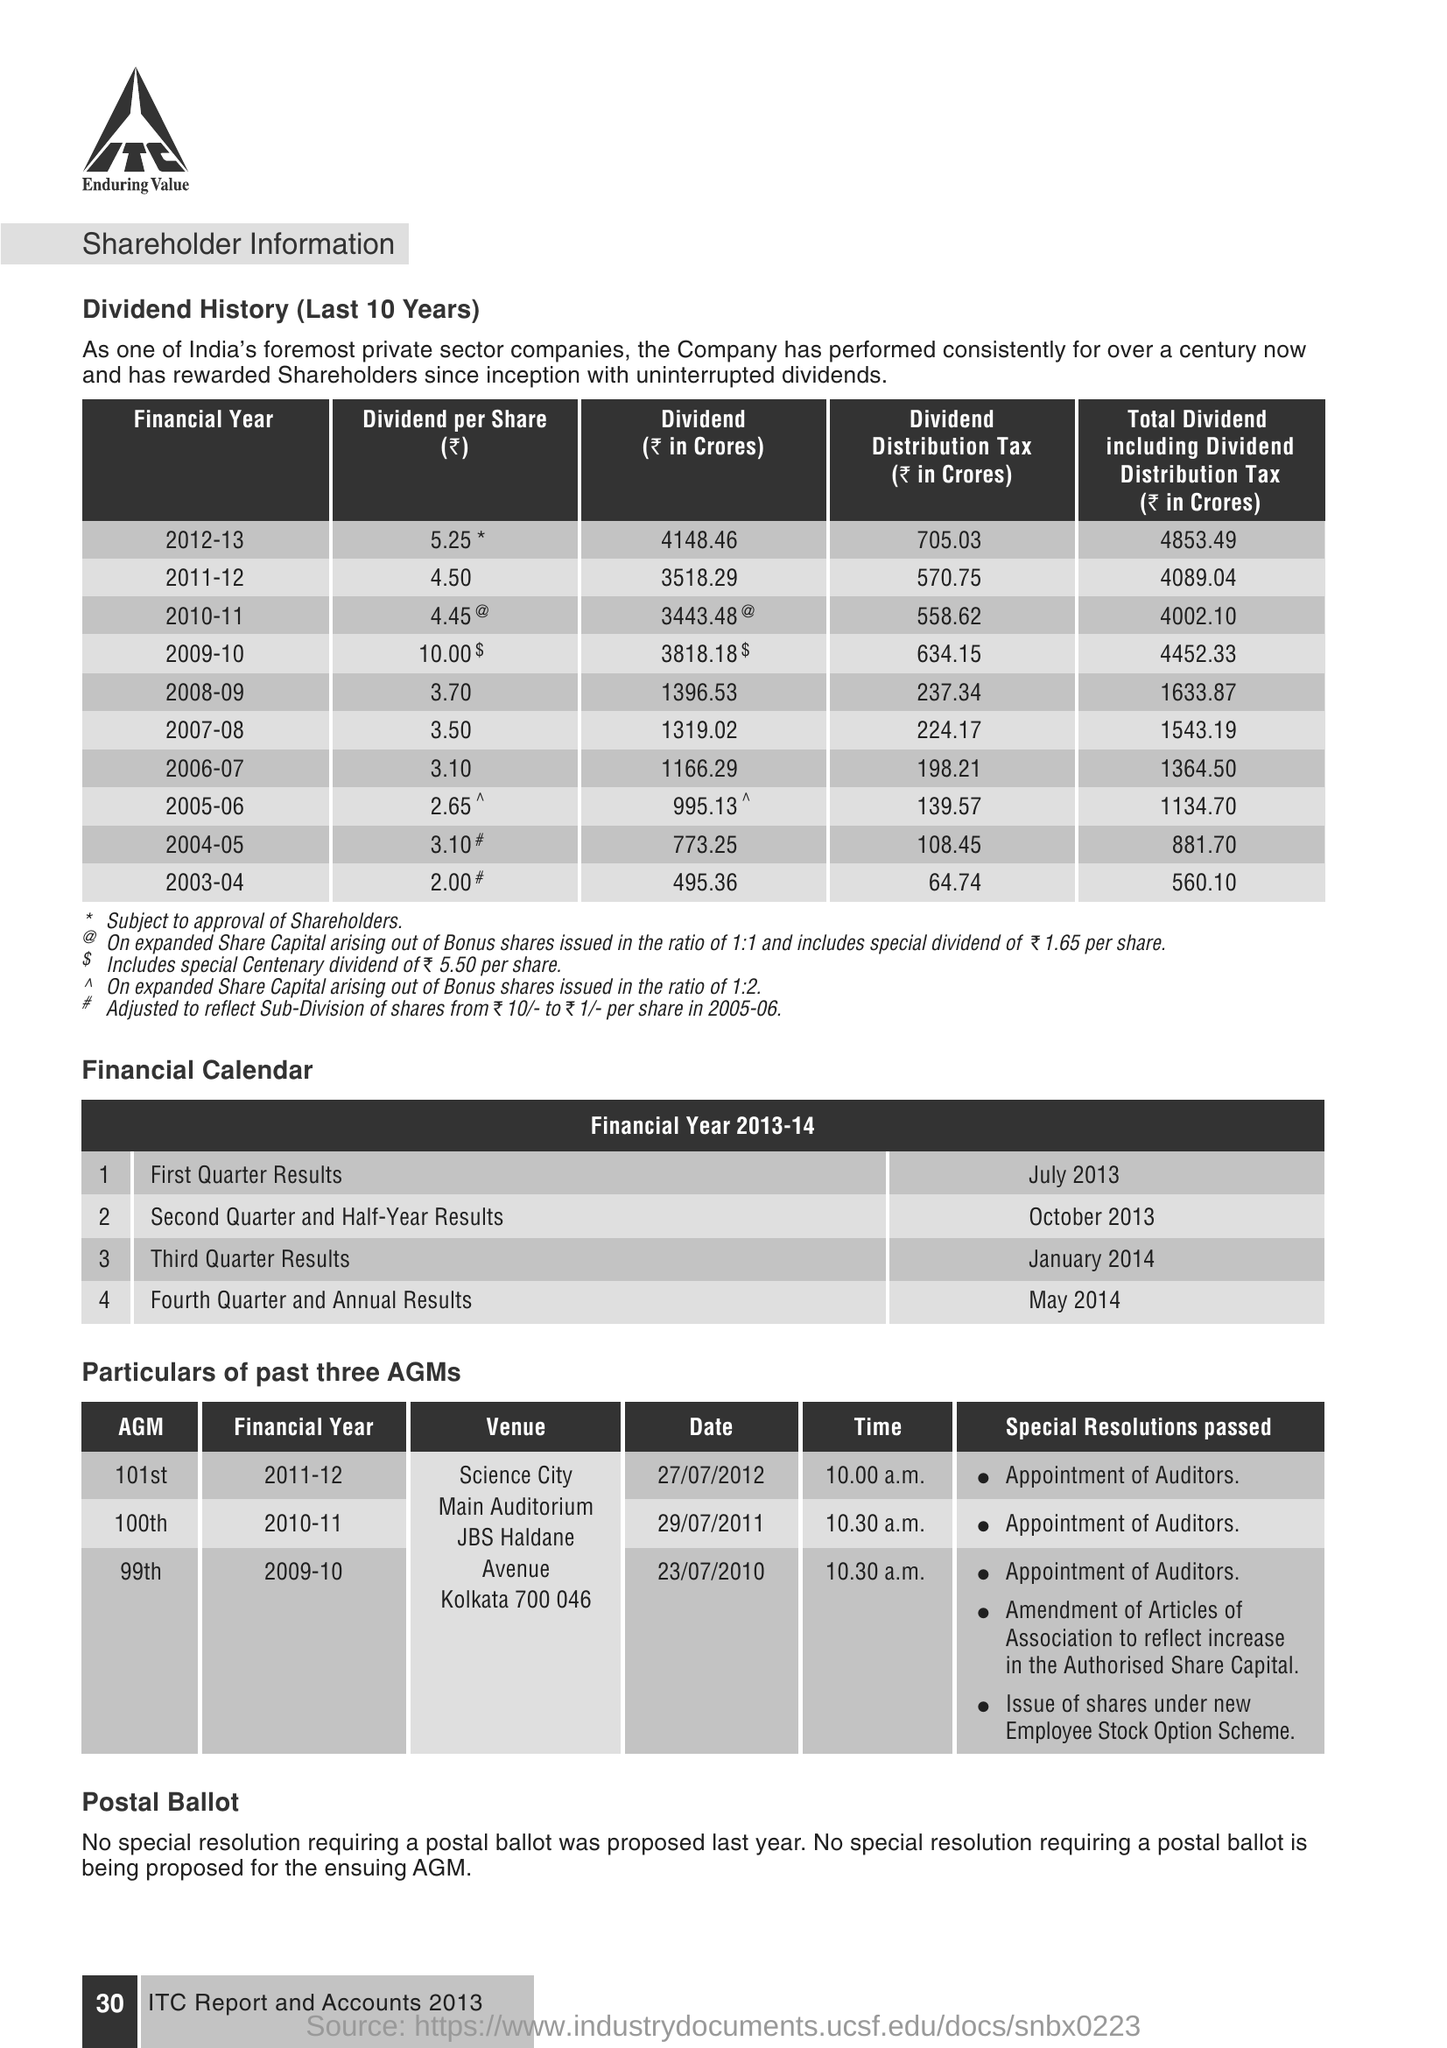Describe the trend in dividend distribution over the last ten years as shown in the image. Over the last ten years, the trend in dividend distribution has seen a consistent growth. Starting from a dividend per share of 2.65 INR in 2005-06 to a peak of 5.25 INR in 2012-13. The dividend distribution has largely increased, reflecting the company's strong financial performance and commitment to rewarding its shareholders. 